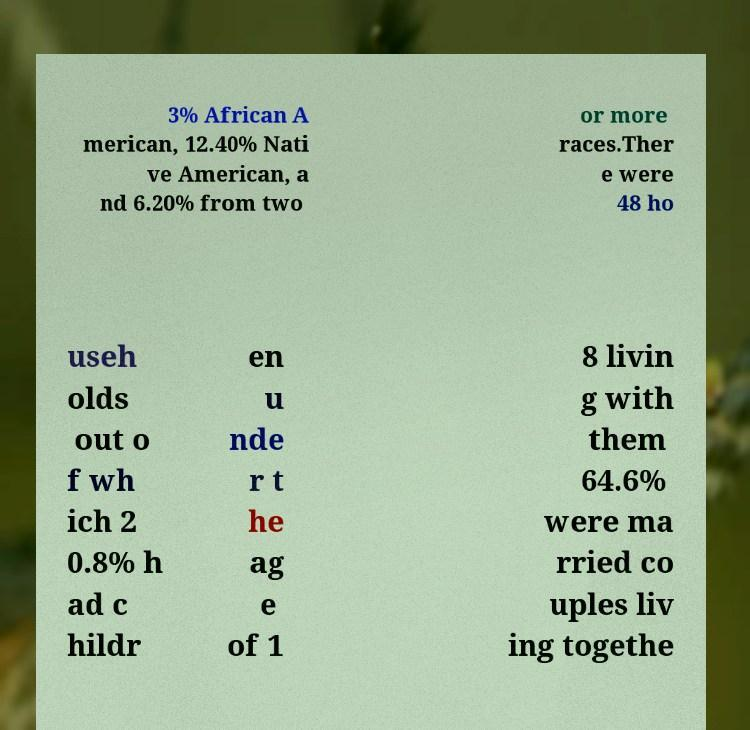Can you read and provide the text displayed in the image?This photo seems to have some interesting text. Can you extract and type it out for me? 3% African A merican, 12.40% Nati ve American, a nd 6.20% from two or more races.Ther e were 48 ho useh olds out o f wh ich 2 0.8% h ad c hildr en u nde r t he ag e of 1 8 livin g with them 64.6% were ma rried co uples liv ing togethe 